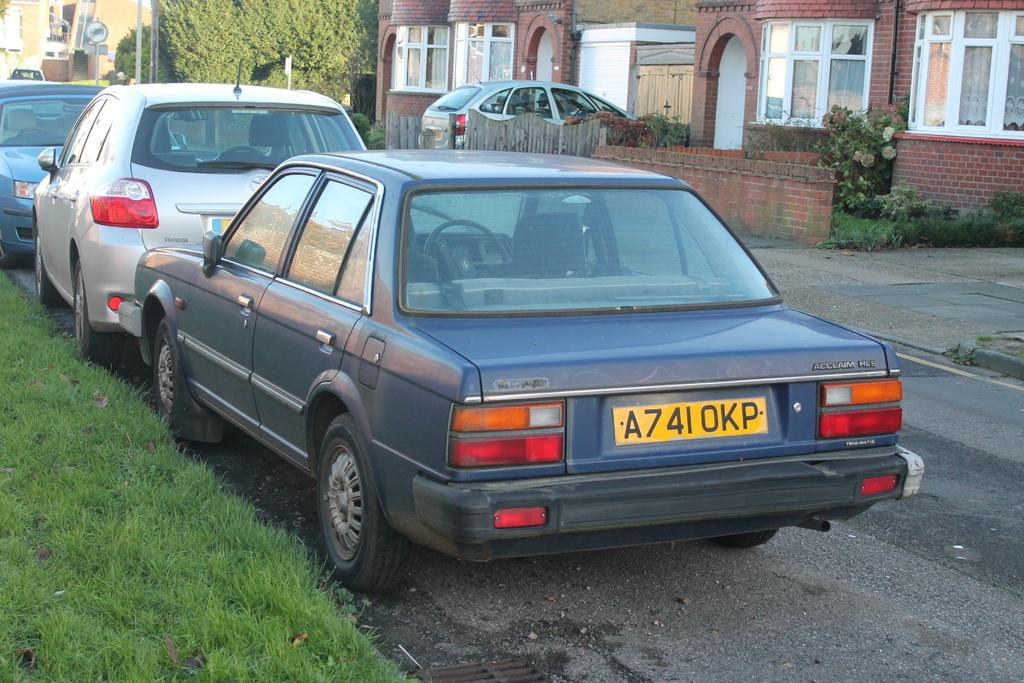What type of vehicles are on the floor in the image? There are motor vehicles on the floor in the image. What kind of fencing can be seen in the image? There are wooden fences in the image. What structures are visible in the image? There are buildings in the image. What type of signage is present in the image? There are sign boards in the image. What type of vegetation is present in the image? Bushes are present in the image. What type of ground cover is visible in the image? Grass is visible in the image. What type of design can be seen on the stream in the image? There is no stream present in the image; it features motor vehicles, wooden fences, buildings, sign boards, bushes, and grass. What riddle is being solved by the motor vehicles in the image? Motor vehicles do not solve riddles; they are inanimate objects used for transportation. 